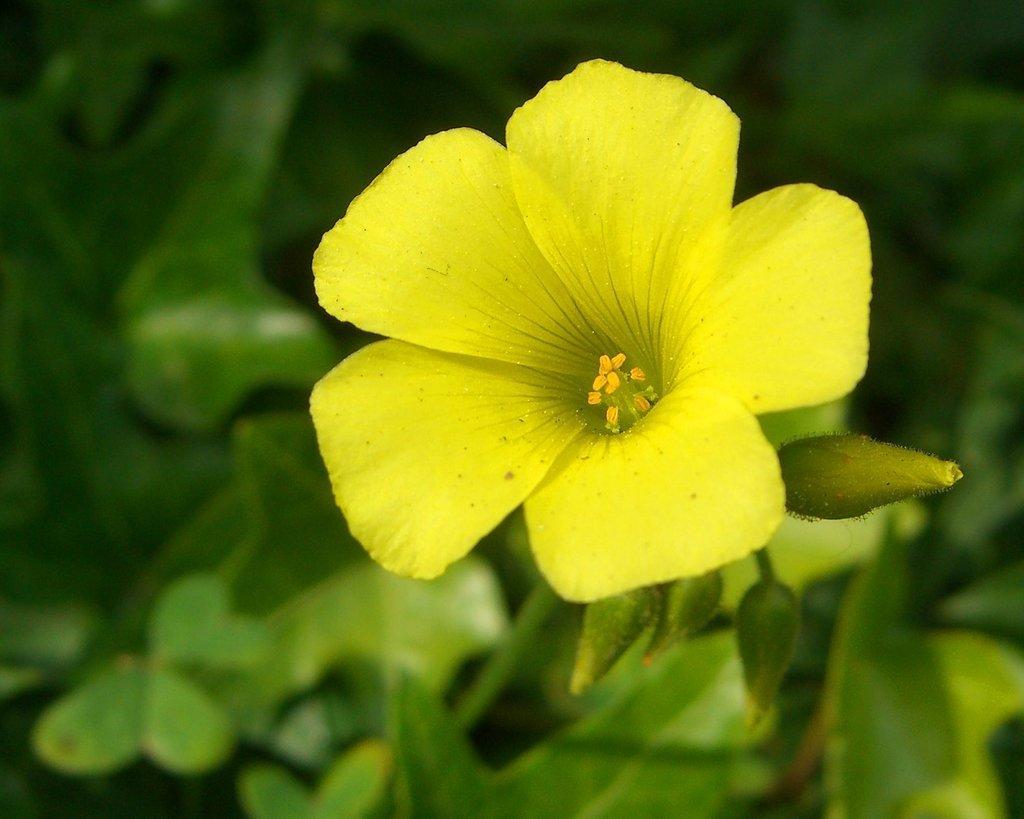In one or two sentences, can you explain what this image depicts? In this image I can see a yellow color flower and few green leaves. Background is blurred. 